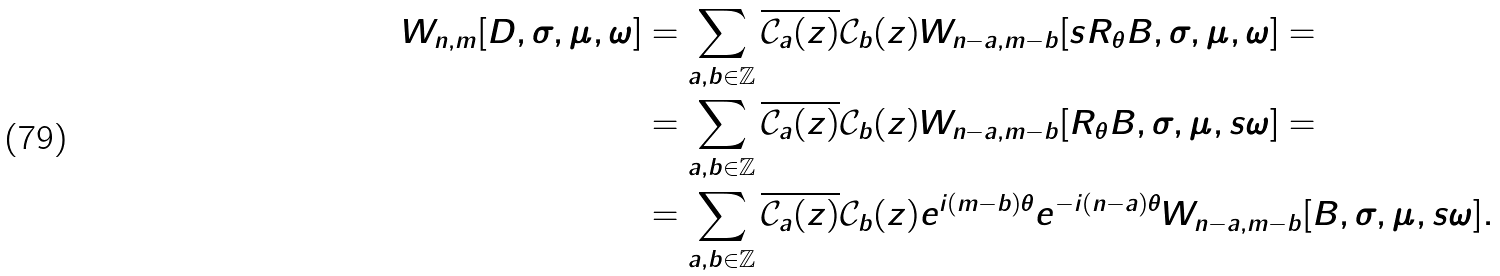<formula> <loc_0><loc_0><loc_500><loc_500>W _ { n , m } [ D , \sigma , \mu , \omega ] & = \sum _ { a , b \in \mathbb { Z } } \overline { \mathcal { C } _ { a } ( z ) } \mathcal { C } _ { b } ( z ) W _ { n - a , m - b } [ s R _ { \theta } B , \sigma , \mu , \omega ] = \\ & = \sum _ { a , b \in \mathbb { Z } } \overline { \mathcal { C } _ { a } ( z ) } \mathcal { C } _ { b } ( z ) W _ { n - a , m - b } [ R _ { \theta } B , \sigma , \mu , s \omega ] = \\ & = \sum _ { a , b \in \mathbb { Z } } \overline { \mathcal { C } _ { a } ( z ) } \mathcal { C } _ { b } ( z ) e ^ { i ( m - b ) \theta } e ^ { - i ( n - a ) \theta } W _ { n - a , m - b } [ B , \sigma , \mu , s \omega ] .</formula> 